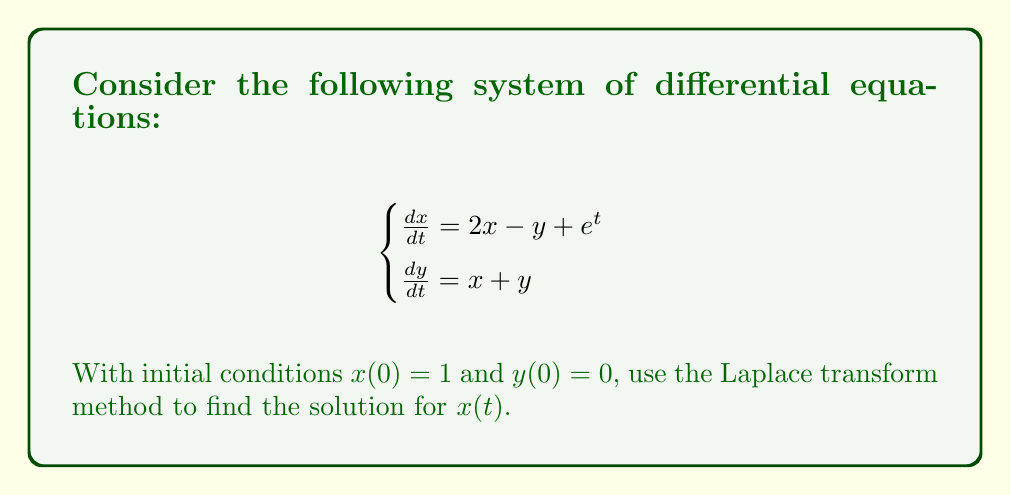Could you help me with this problem? Let's solve this step-by-step using the Laplace transform method:

1) First, let's take the Laplace transform of both equations:
   $$\begin{cases}
   s\mathcal{L}\{x\} - x(0) = 2\mathcal{L}\{x\} - \mathcal{L}\{y\} + \mathcal{L}\{e^t\} \\
   s\mathcal{L}\{y\} - y(0) = \mathcal{L}\{x\} + \mathcal{L}\{y\}
   \end{cases}$$

2) Substitute the initial conditions and simplify:
   $$\begin{cases}
   sX(s) - 1 = 2X(s) - Y(s) + \frac{1}{s-1} \\
   sY(s) = X(s) + Y(s)
   \end{cases}$$

3) Rearrange the equations:
   $$\begin{cases}
   (s-2)X(s) + Y(s) = 1 + \frac{1}{s-1} \\
   -X(s) + (s-1)Y(s) = 0
   \end{cases}$$

4) Solve for X(s) using Cramer's rule:
   $$X(s) = \frac{\begin{vmatrix}
   1 + \frac{1}{s-1} & 1 \\
   0 & s-1
   \end{vmatrix}}{\begin{vmatrix}
   s-2 & 1 \\
   -1 & s-1
   \end{vmatrix}}$$

5) Simplify:
   $$X(s) = \frac{(1 + \frac{1}{s-1})(s-1)}{(s-2)(s-1)+1} = \frac{s + \frac{s}{s-1}}{s^2-2s+1} = \frac{s^2-s+s}{(s-1)(s^2-2s+1)}$$

6) Factor the denominator:
   $$X(s) = \frac{s^2}{(s-1)^3}$$

7) Use partial fraction decomposition:
   $$X(s) = \frac{A}{s-1} + \frac{B}{(s-1)^2} + \frac{C}{(s-1)^3}$$

8) Solve for A, B, and C:
   $$A = 1, B = -1, C = 1$$

9) Take the inverse Laplace transform:
   $$x(t) = \mathcal{L}^{-1}\{X(s)\} = e^t - te^t + \frac{1}{2}t^2e^t$$
Answer: $x(t) = e^t - te^t + \frac{1}{2}t^2e^t$ 